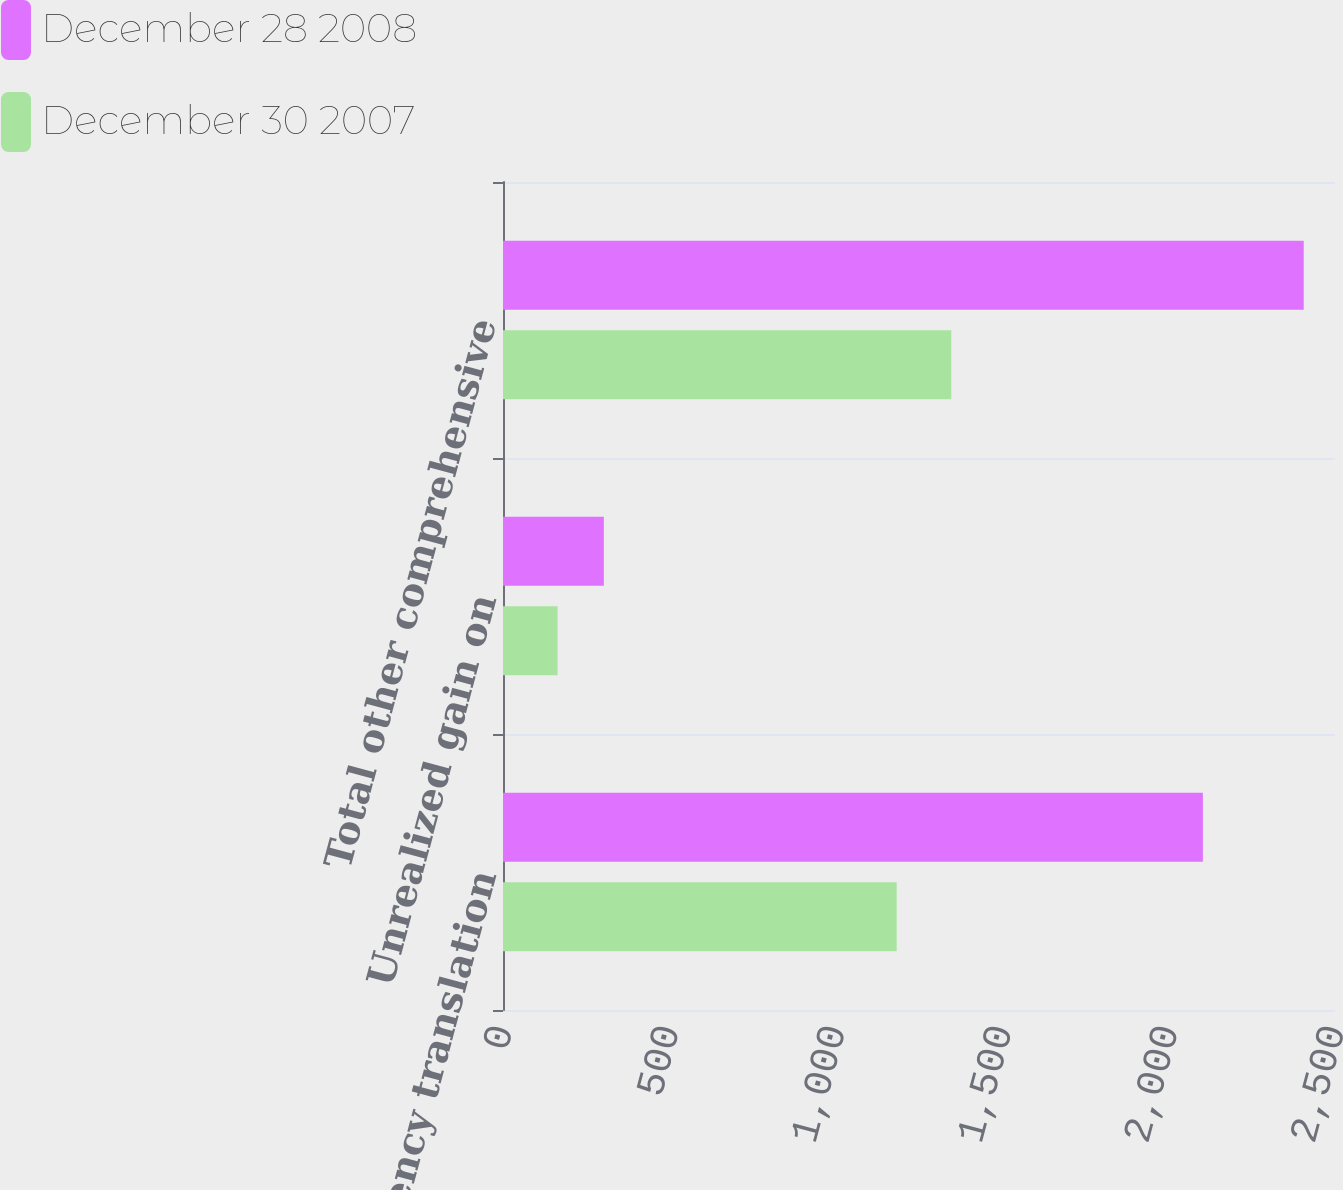<chart> <loc_0><loc_0><loc_500><loc_500><stacked_bar_chart><ecel><fcel>Foreign currency translation<fcel>Unrealized gain on<fcel>Total other comprehensive<nl><fcel>December 28 2008<fcel>2103<fcel>303<fcel>2406<nl><fcel>December 30 2007<fcel>1183<fcel>164<fcel>1347<nl></chart> 